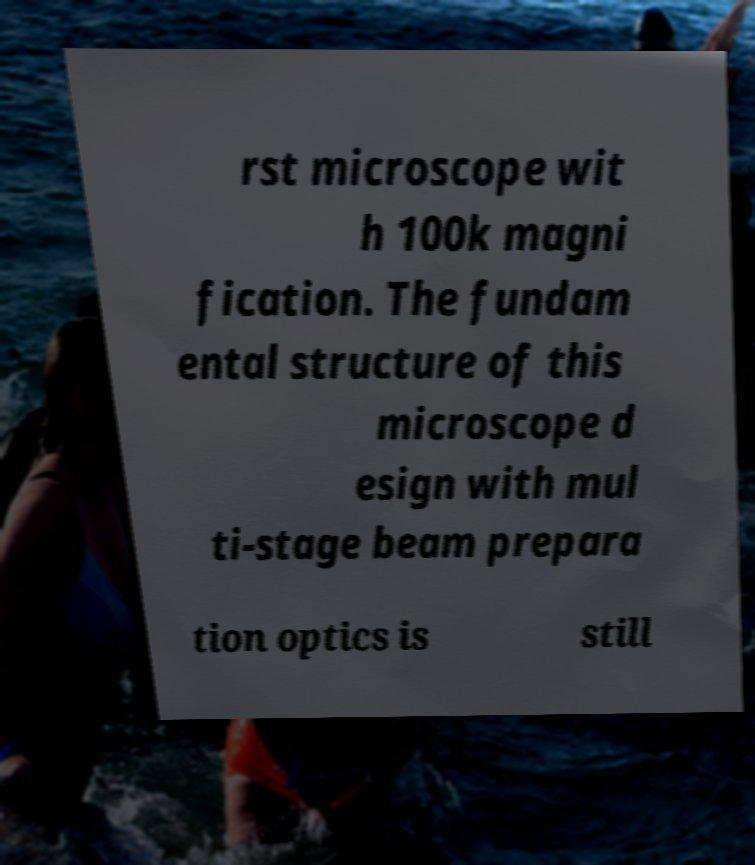What messages or text are displayed in this image? I need them in a readable, typed format. rst microscope wit h 100k magni fication. The fundam ental structure of this microscope d esign with mul ti-stage beam prepara tion optics is still 